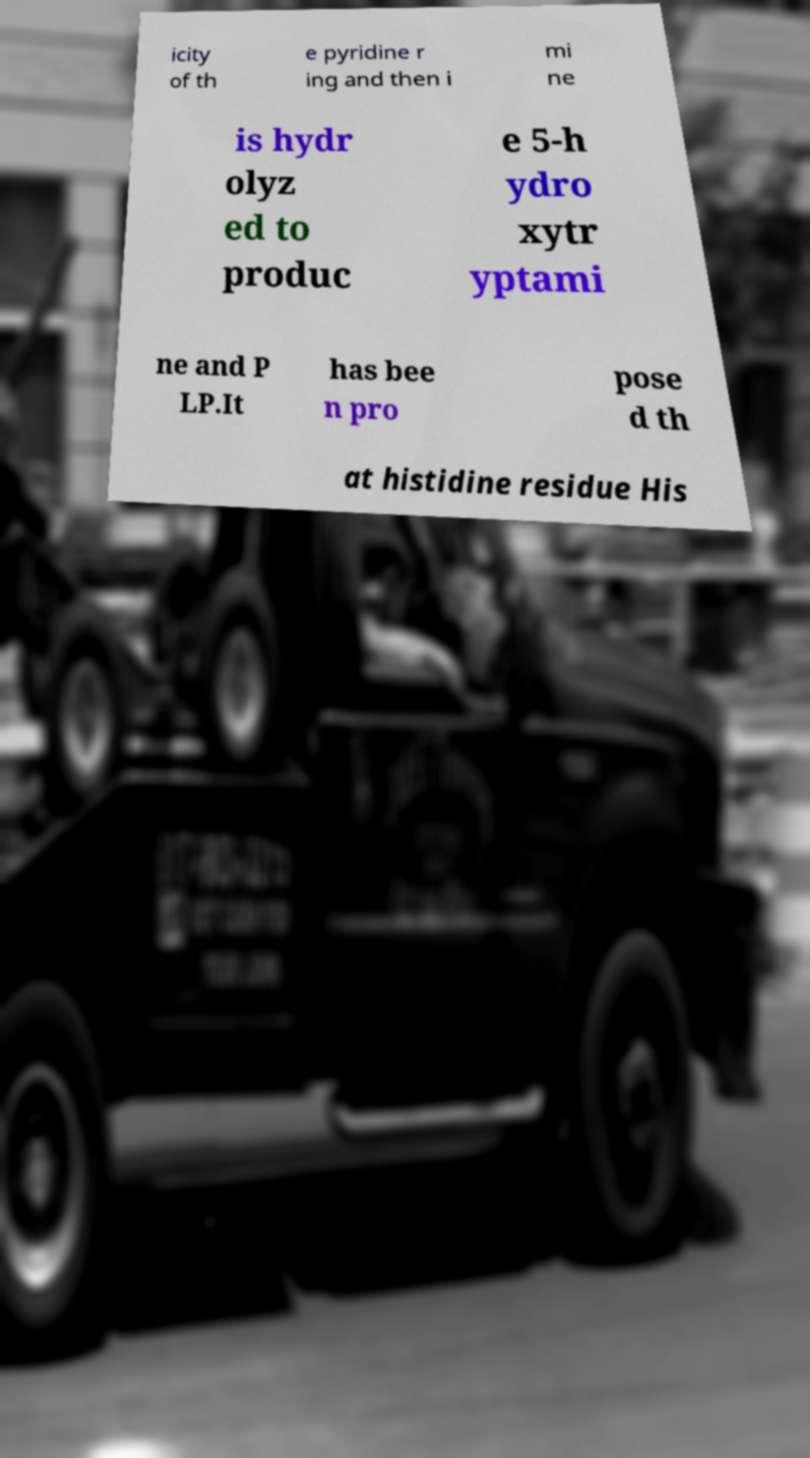Please read and relay the text visible in this image. What does it say? icity of th e pyridine r ing and then i mi ne is hydr olyz ed to produc e 5-h ydro xytr yptami ne and P LP.It has bee n pro pose d th at histidine residue His 